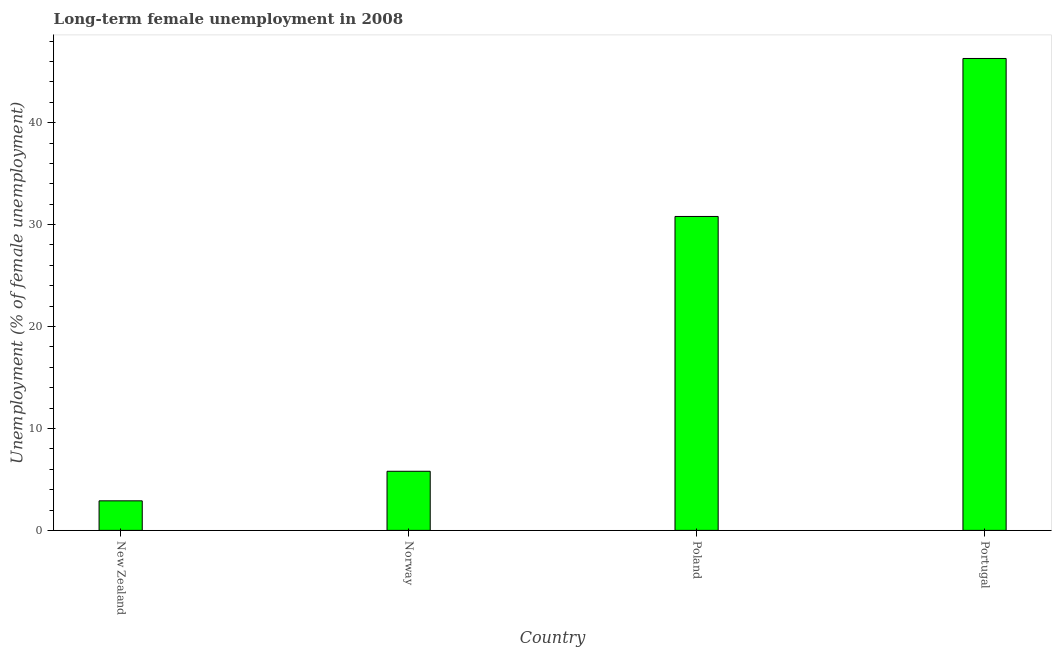What is the title of the graph?
Offer a very short reply. Long-term female unemployment in 2008. What is the label or title of the X-axis?
Your answer should be compact. Country. What is the label or title of the Y-axis?
Your response must be concise. Unemployment (% of female unemployment). What is the long-term female unemployment in New Zealand?
Give a very brief answer. 2.9. Across all countries, what is the maximum long-term female unemployment?
Give a very brief answer. 46.3. Across all countries, what is the minimum long-term female unemployment?
Offer a terse response. 2.9. In which country was the long-term female unemployment maximum?
Provide a succinct answer. Portugal. In which country was the long-term female unemployment minimum?
Offer a terse response. New Zealand. What is the sum of the long-term female unemployment?
Give a very brief answer. 85.8. What is the difference between the long-term female unemployment in New Zealand and Poland?
Ensure brevity in your answer.  -27.9. What is the average long-term female unemployment per country?
Your answer should be very brief. 21.45. What is the median long-term female unemployment?
Your answer should be very brief. 18.3. In how many countries, is the long-term female unemployment greater than 44 %?
Offer a terse response. 1. What is the difference between the highest and the second highest long-term female unemployment?
Your response must be concise. 15.5. What is the difference between the highest and the lowest long-term female unemployment?
Keep it short and to the point. 43.4. What is the difference between two consecutive major ticks on the Y-axis?
Keep it short and to the point. 10. Are the values on the major ticks of Y-axis written in scientific E-notation?
Provide a short and direct response. No. What is the Unemployment (% of female unemployment) in New Zealand?
Keep it short and to the point. 2.9. What is the Unemployment (% of female unemployment) in Norway?
Give a very brief answer. 5.8. What is the Unemployment (% of female unemployment) of Poland?
Offer a terse response. 30.8. What is the Unemployment (% of female unemployment) of Portugal?
Ensure brevity in your answer.  46.3. What is the difference between the Unemployment (% of female unemployment) in New Zealand and Poland?
Provide a succinct answer. -27.9. What is the difference between the Unemployment (% of female unemployment) in New Zealand and Portugal?
Make the answer very short. -43.4. What is the difference between the Unemployment (% of female unemployment) in Norway and Poland?
Make the answer very short. -25. What is the difference between the Unemployment (% of female unemployment) in Norway and Portugal?
Your response must be concise. -40.5. What is the difference between the Unemployment (% of female unemployment) in Poland and Portugal?
Give a very brief answer. -15.5. What is the ratio of the Unemployment (% of female unemployment) in New Zealand to that in Norway?
Offer a terse response. 0.5. What is the ratio of the Unemployment (% of female unemployment) in New Zealand to that in Poland?
Your answer should be very brief. 0.09. What is the ratio of the Unemployment (% of female unemployment) in New Zealand to that in Portugal?
Keep it short and to the point. 0.06. What is the ratio of the Unemployment (% of female unemployment) in Norway to that in Poland?
Offer a terse response. 0.19. What is the ratio of the Unemployment (% of female unemployment) in Poland to that in Portugal?
Provide a short and direct response. 0.67. 